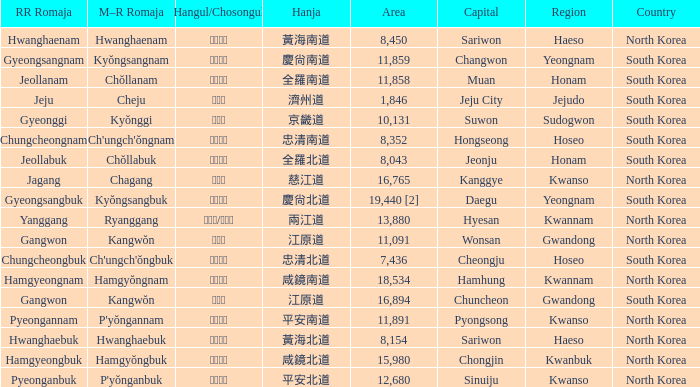Which country has a city with a Hanja of 平安北道? North Korea. 